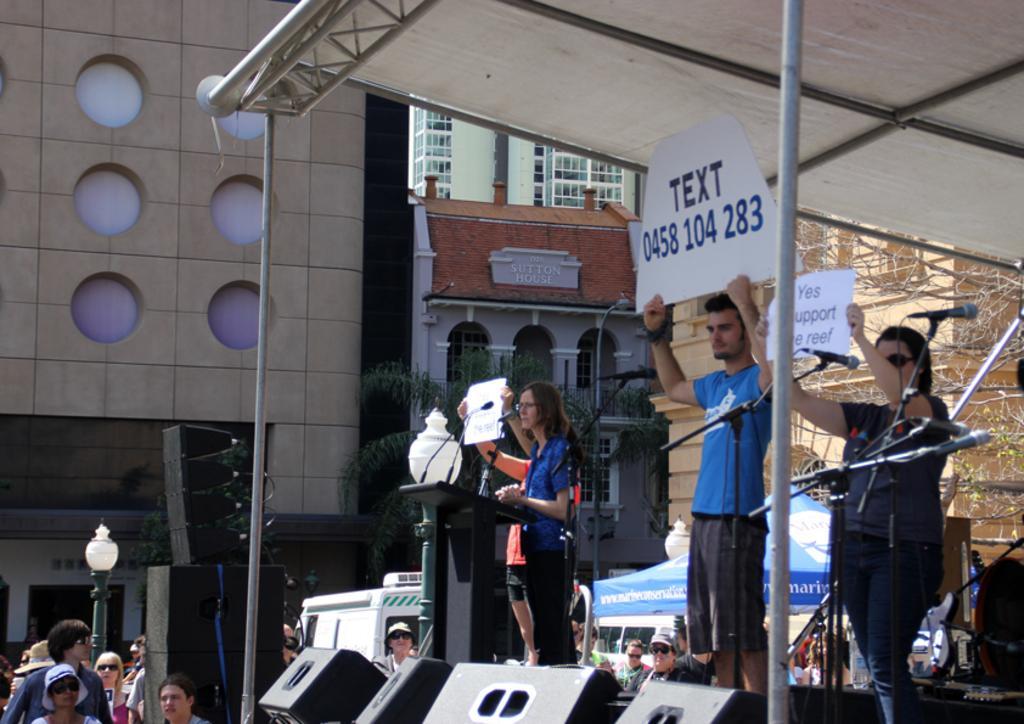How would you summarize this image in a sentence or two? In this picture, on the right side, we can see three people are standing in front of the microphone and there are also holding some papers. On the right side top, we can see metal roof. On the left side, we can see group of people. In the middle of the image, we can see speakers. In the background, we can see some vehicles, tents, buildings, trees. 